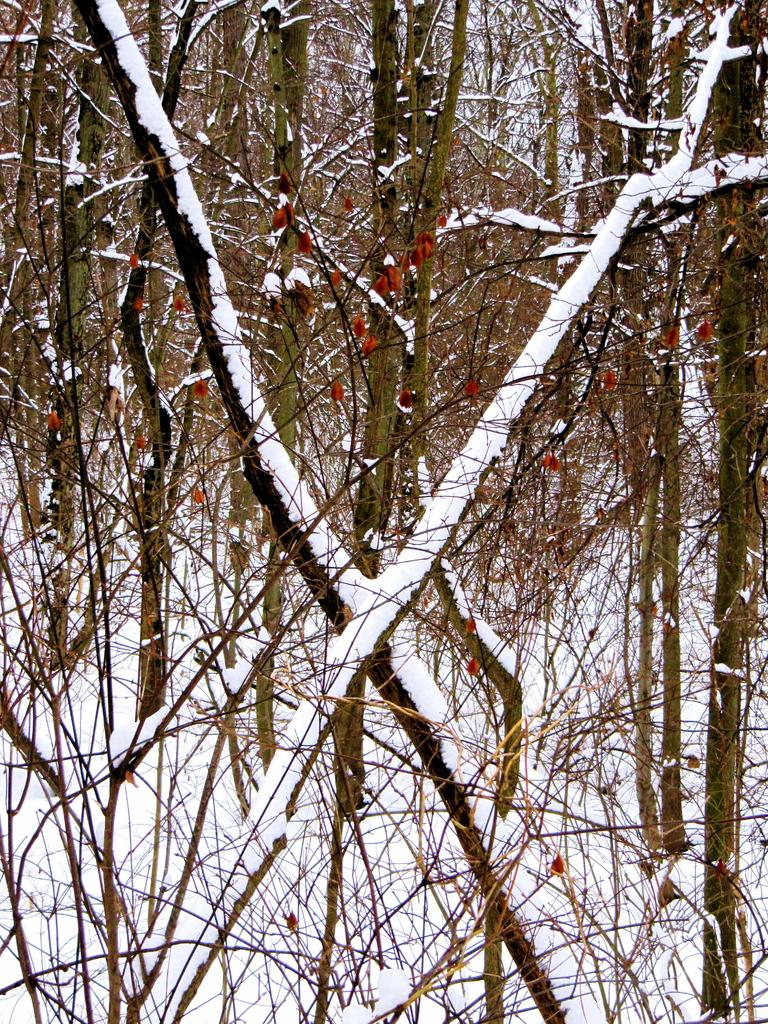What type of vegetation is present in the image? There are trees in the image. How are the trees in the image affected by the weather? The trees are covered with snow. What is visible at the bottom of the image? There is snow at the bottom of the image. What type of attraction can be seen in the image? There is no attraction present in the image; it features trees covered in snow. How does the spoon interact with the trees in the image? There is no spoon present in the image, so it cannot interact with the trees. 